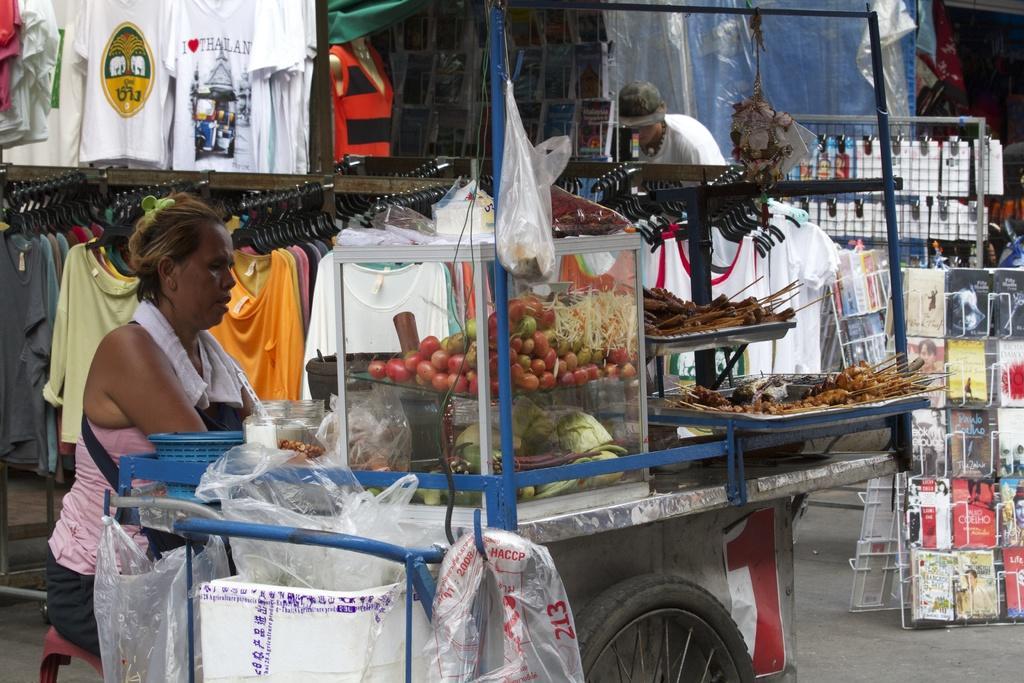Can you describe this image briefly? In this image, we can see people and one of them is sitting on the chair and there is a cycle and on the cycle, we can see a glass box with some vegetables and there is a tray filled with some food items and a jar and some bags which are hanging to the cycle and in the background, we can see clothes to the hangers and there are sheets, curtains and books in the book stand and there are some other cloths and an object which is hanging. At the bottom, there is road. 